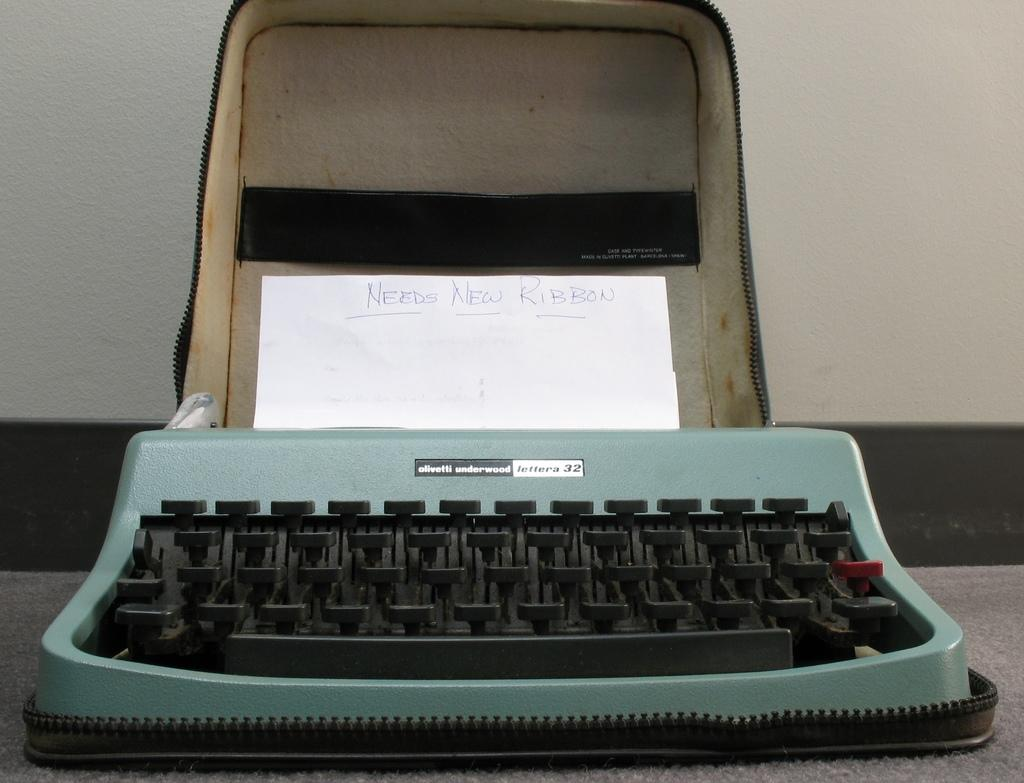<image>
Write a terse but informative summary of the picture. A handwritten reminder note is placed inside the olivetti underwood typewriter to buy more ribbon. 